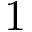<formula> <loc_0><loc_0><loc_500><loc_500>1</formula> 